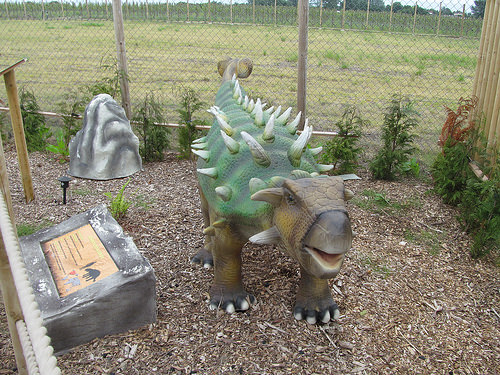<image>
Is there a rock in front of the post? No. The rock is not in front of the post. The spatial positioning shows a different relationship between these objects. 